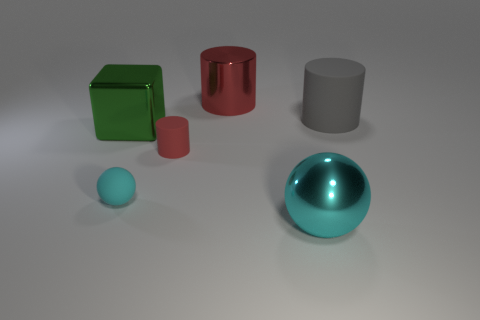Subtract all tiny cylinders. How many cylinders are left? 2 Subtract all gray cylinders. How many cylinders are left? 2 Add 1 cyan metal balls. How many objects exist? 7 Subtract 1 cylinders. How many cylinders are left? 2 Subtract all spheres. How many objects are left? 4 Subtract all blue spheres. How many gray cylinders are left? 1 Add 2 red shiny objects. How many red shiny objects are left? 3 Add 1 small metallic cylinders. How many small metallic cylinders exist? 1 Subtract 0 brown balls. How many objects are left? 6 Subtract all brown spheres. Subtract all gray blocks. How many spheres are left? 2 